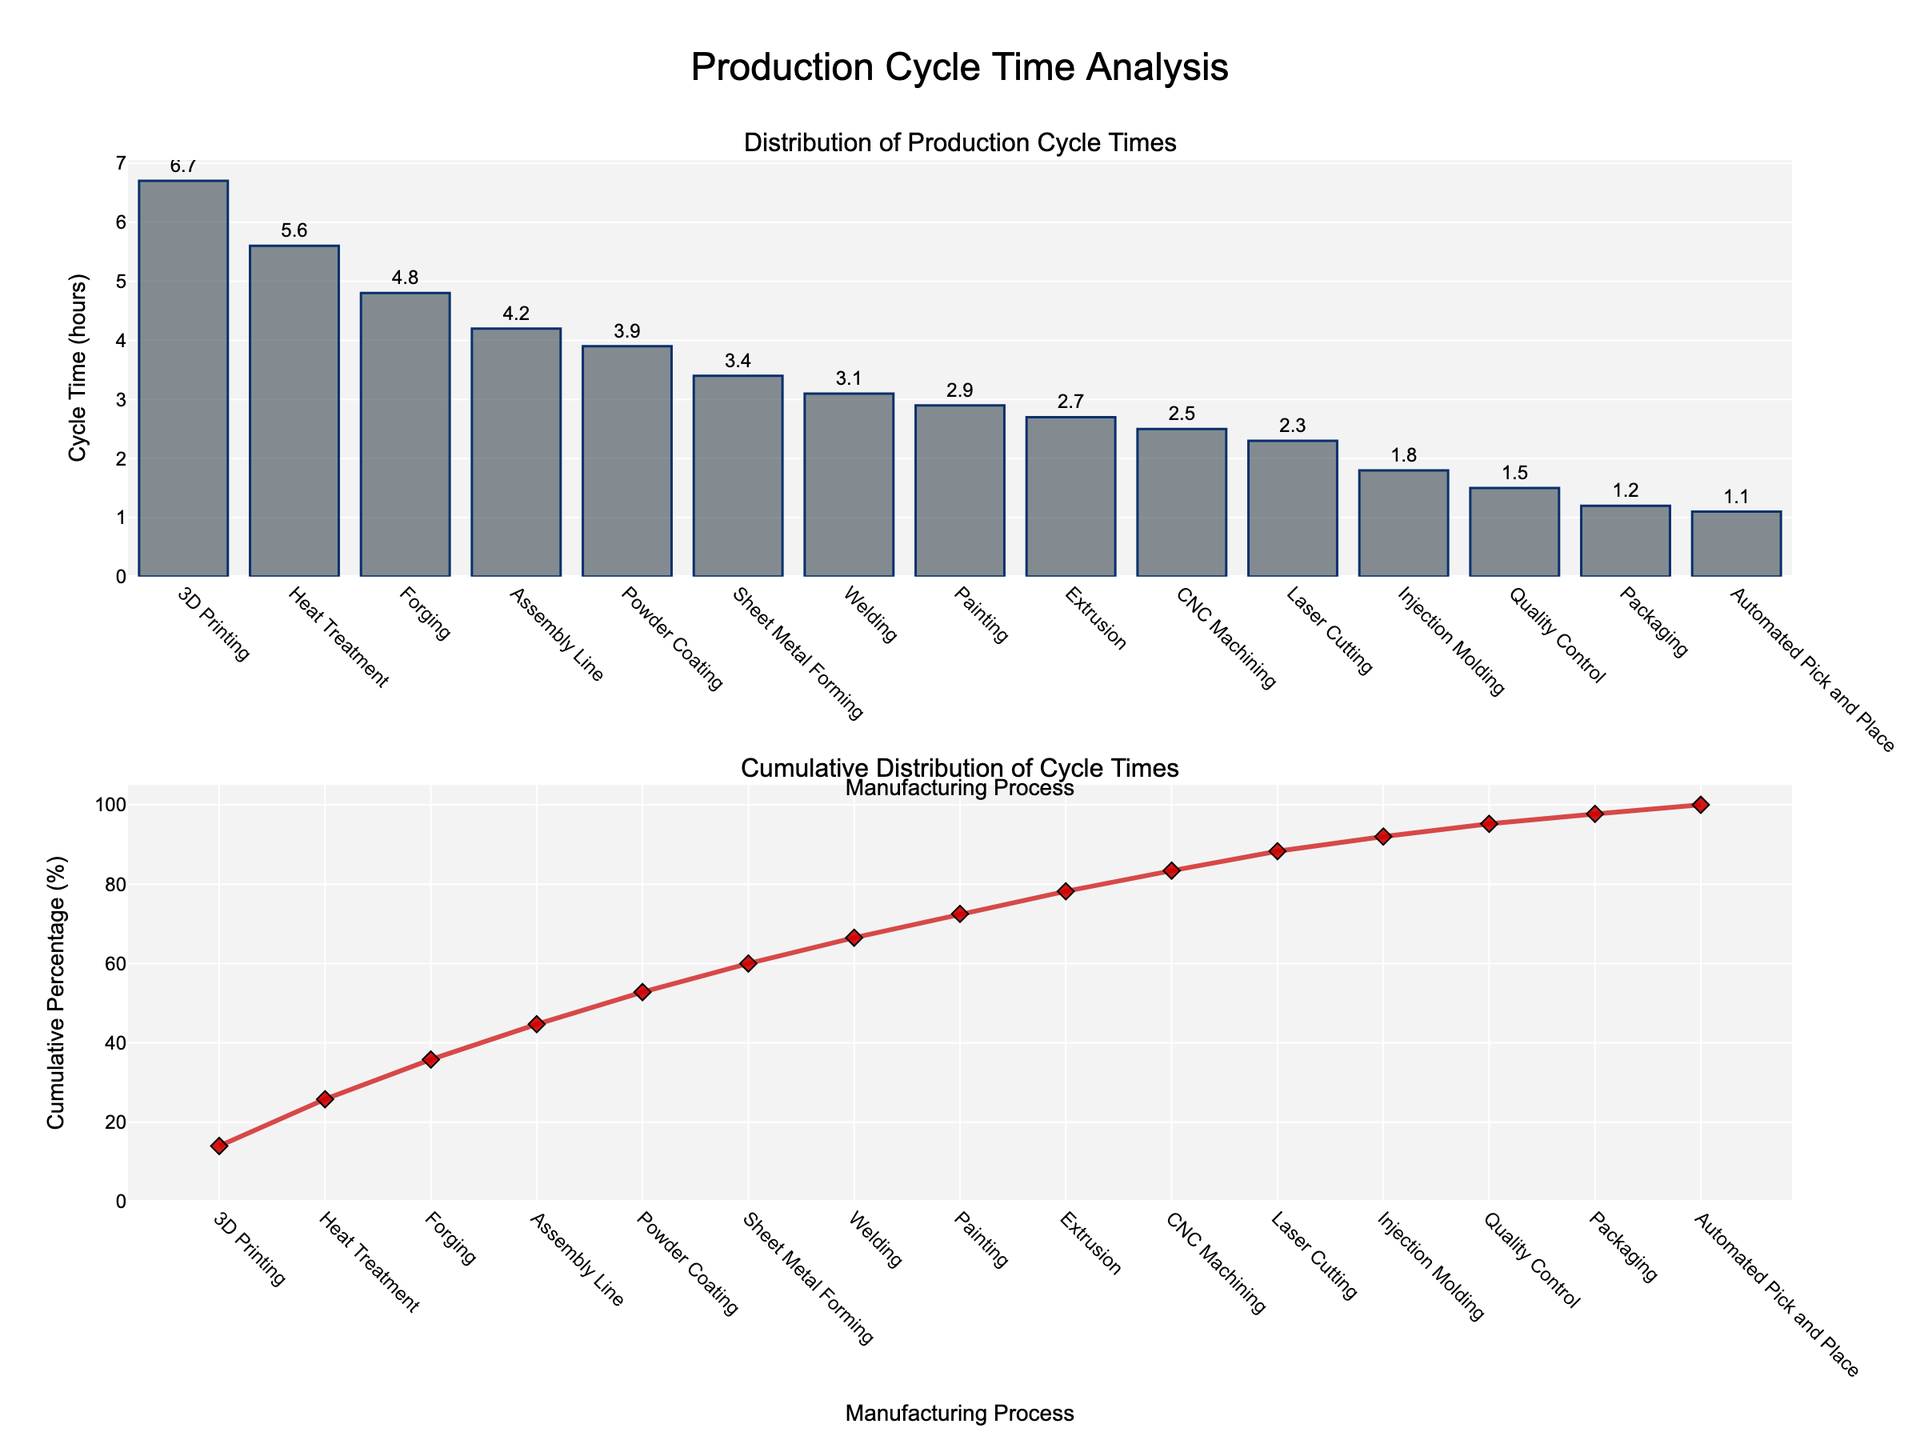What is the title of the figure? The title is located at the top of the plot and is usually in larger, bold font compared to other texts on the plot.
Answer: iOS Version Adoption Rates Over Time How many iOS versions are represented in the figure? The figure has several subplots, each with a title near the top. Each title represents an iOS version. By counting these subplots, we can identify the number of iOS versions.
Answer: 6 Describe the trend in adoption rates for iOS 16. Look at the subplot titled "iOS 16." Track the line from the leftmost point to the rightmost point to observe how the values change over time.
Answer: The adoption rate increases steeply from 0% to 81% between Dec 2021 and Jun 2023 Which iOS version had the highest adoption rate by Jun 2023? Compare the values at Jun 2023 for each subplot. Find the highest value among them.
Answer: iOS 16 Is there any iOS version whose adoption rate increased between every consecutive time point? Check each subplot and observe if the adoption rate consistently increased without any decrease at each consecutive time point.
Answer: iOS 15 between Dec 2020 and Jun 2022 What is the adoption rate of iOS 14 in Jun 2022? Locate the subplot for iOS 14. Follow the line to the point corresponding to Jun 2022 and read the value.
Answer: 10% Which iOS version had the largest drop in adoption rate between two consecutive time points? Calculate the difference in adoption rates between consecutive time points for all versions and identify the largest drop.
Answer: iOS 14 (Dec 2020 to Dec 2021, from 85% to 26%) Compare the adoption rates of iOS 13 and iOS 11 and below in Dec 2022. Which one is higher? Locate the points for Dec 2022 in both the iOS 13 and iOS 11 and below subplots and compare their values.
Answer: iOS 13 (1% vs 0.5%) Between which two time points did iOS 15 see the most significant increase in adoption rate? Examine the changes in adoption rate between each pair of consecutive time points in the iOS 15 subplot and identify the largest increase.
Answer: Dec 2020 to Dec 2021 (0% to 72%) What is the combined adoption rate of iOS 14 and iOS 13 in Jun 2021? Find the values for iOS 14 and iOS 13 in Jun 2021, then add them together.
Answer: 85 + 12 = 97% 